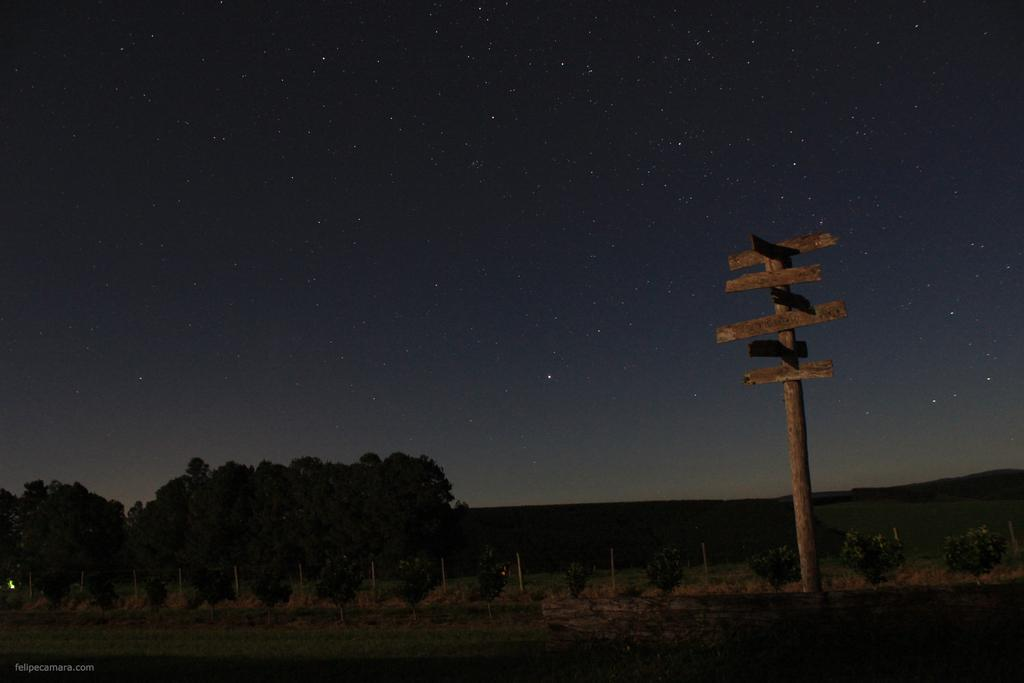What type of vegetation can be seen in the image? There are plants and trees in the image. What is attached to the pole in the image? There are sign boards on the pole in the image. What is visible in the sky in the image? The sky is visible in the image, and stars are visible in the sky. Where is the sink located in the image? There is no sink present in the image. How many children are playing with the rake in the image? There are no children or rake present in the image. 